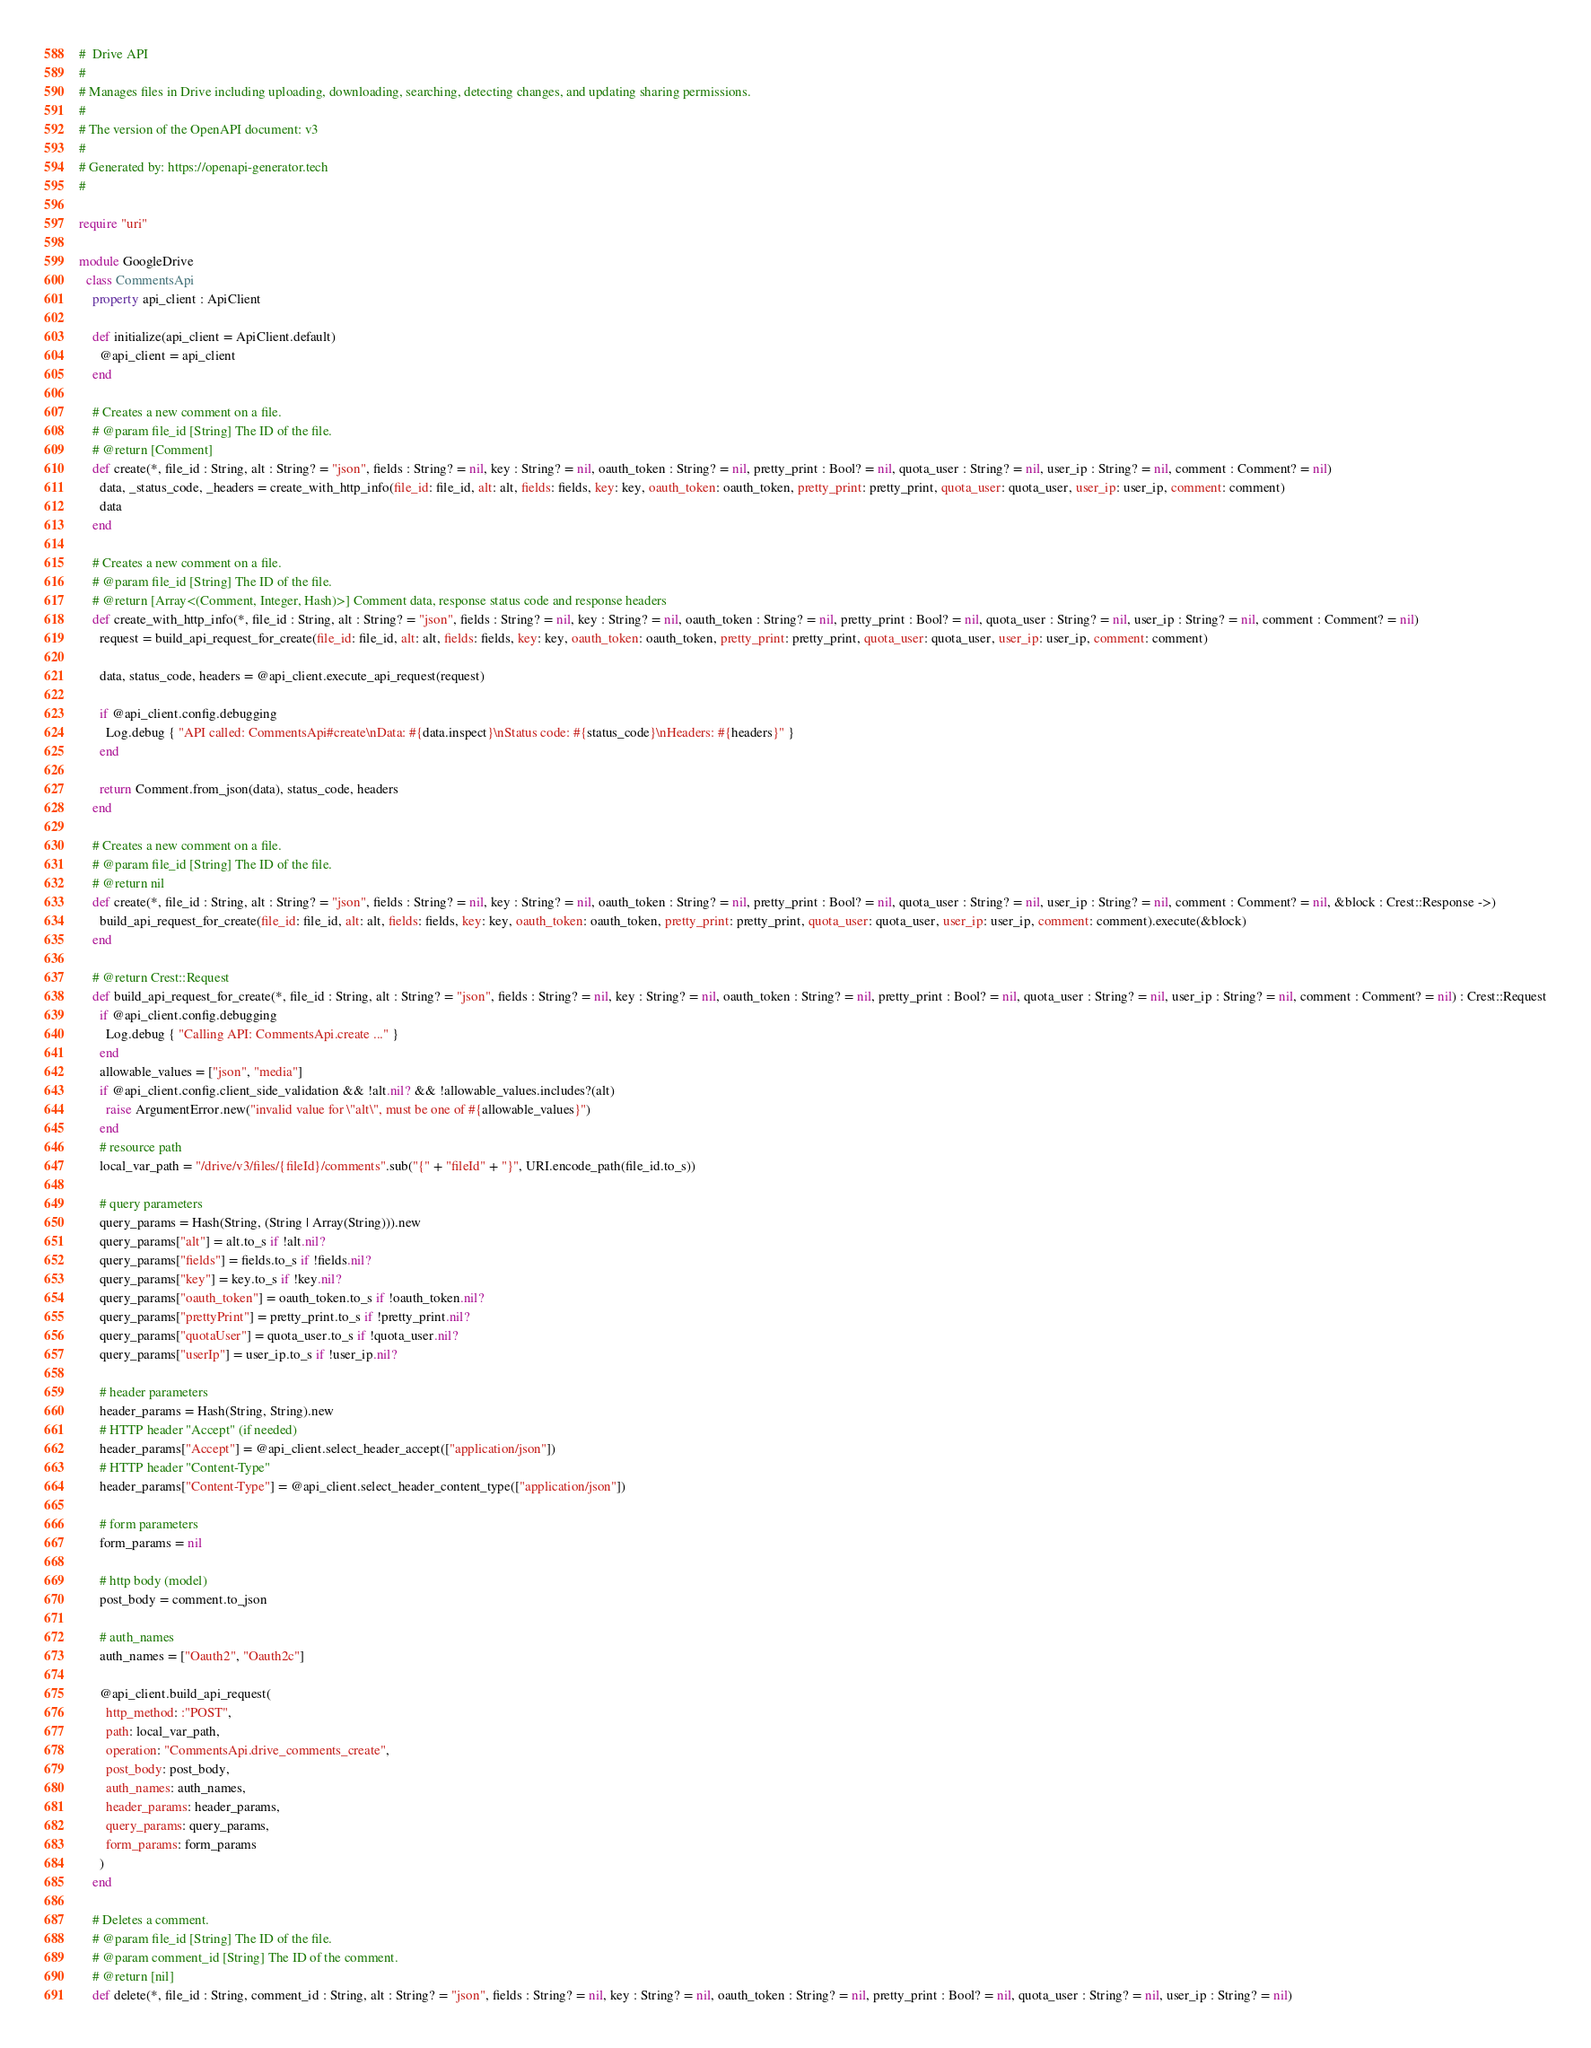<code> <loc_0><loc_0><loc_500><loc_500><_Crystal_>#  Drive API
#
# Manages files in Drive including uploading, downloading, searching, detecting changes, and updating sharing permissions.
#
# The version of the OpenAPI document: v3
#
# Generated by: https://openapi-generator.tech
#

require "uri"

module GoogleDrive
  class CommentsApi
    property api_client : ApiClient

    def initialize(api_client = ApiClient.default)
      @api_client = api_client
    end

    # Creates a new comment on a file.
    # @param file_id [String] The ID of the file.
    # @return [Comment]
    def create(*, file_id : String, alt : String? = "json", fields : String? = nil, key : String? = nil, oauth_token : String? = nil, pretty_print : Bool? = nil, quota_user : String? = nil, user_ip : String? = nil, comment : Comment? = nil)
      data, _status_code, _headers = create_with_http_info(file_id: file_id, alt: alt, fields: fields, key: key, oauth_token: oauth_token, pretty_print: pretty_print, quota_user: quota_user, user_ip: user_ip, comment: comment)
      data
    end

    # Creates a new comment on a file.
    # @param file_id [String] The ID of the file.
    # @return [Array<(Comment, Integer, Hash)>] Comment data, response status code and response headers
    def create_with_http_info(*, file_id : String, alt : String? = "json", fields : String? = nil, key : String? = nil, oauth_token : String? = nil, pretty_print : Bool? = nil, quota_user : String? = nil, user_ip : String? = nil, comment : Comment? = nil)
      request = build_api_request_for_create(file_id: file_id, alt: alt, fields: fields, key: key, oauth_token: oauth_token, pretty_print: pretty_print, quota_user: quota_user, user_ip: user_ip, comment: comment)

      data, status_code, headers = @api_client.execute_api_request(request)

      if @api_client.config.debugging
        Log.debug { "API called: CommentsApi#create\nData: #{data.inspect}\nStatus code: #{status_code}\nHeaders: #{headers}" }
      end

      return Comment.from_json(data), status_code, headers
    end

    # Creates a new comment on a file.
    # @param file_id [String] The ID of the file.
    # @return nil
    def create(*, file_id : String, alt : String? = "json", fields : String? = nil, key : String? = nil, oauth_token : String? = nil, pretty_print : Bool? = nil, quota_user : String? = nil, user_ip : String? = nil, comment : Comment? = nil, &block : Crest::Response ->)
      build_api_request_for_create(file_id: file_id, alt: alt, fields: fields, key: key, oauth_token: oauth_token, pretty_print: pretty_print, quota_user: quota_user, user_ip: user_ip, comment: comment).execute(&block)
    end

    # @return Crest::Request
    def build_api_request_for_create(*, file_id : String, alt : String? = "json", fields : String? = nil, key : String? = nil, oauth_token : String? = nil, pretty_print : Bool? = nil, quota_user : String? = nil, user_ip : String? = nil, comment : Comment? = nil) : Crest::Request
      if @api_client.config.debugging
        Log.debug { "Calling API: CommentsApi.create ..." }
      end
      allowable_values = ["json", "media"]
      if @api_client.config.client_side_validation && !alt.nil? && !allowable_values.includes?(alt)
        raise ArgumentError.new("invalid value for \"alt\", must be one of #{allowable_values}")
      end
      # resource path
      local_var_path = "/drive/v3/files/{fileId}/comments".sub("{" + "fileId" + "}", URI.encode_path(file_id.to_s))

      # query parameters
      query_params = Hash(String, (String | Array(String))).new
      query_params["alt"] = alt.to_s if !alt.nil?
      query_params["fields"] = fields.to_s if !fields.nil?
      query_params["key"] = key.to_s if !key.nil?
      query_params["oauth_token"] = oauth_token.to_s if !oauth_token.nil?
      query_params["prettyPrint"] = pretty_print.to_s if !pretty_print.nil?
      query_params["quotaUser"] = quota_user.to_s if !quota_user.nil?
      query_params["userIp"] = user_ip.to_s if !user_ip.nil?

      # header parameters
      header_params = Hash(String, String).new
      # HTTP header "Accept" (if needed)
      header_params["Accept"] = @api_client.select_header_accept(["application/json"])
      # HTTP header "Content-Type"
      header_params["Content-Type"] = @api_client.select_header_content_type(["application/json"])

      # form parameters
      form_params = nil

      # http body (model)
      post_body = comment.to_json

      # auth_names
      auth_names = ["Oauth2", "Oauth2c"]

      @api_client.build_api_request(
        http_method: :"POST",
        path: local_var_path,
        operation: "CommentsApi.drive_comments_create",
        post_body: post_body,
        auth_names: auth_names,
        header_params: header_params,
        query_params: query_params,
        form_params: form_params
      )
    end

    # Deletes a comment.
    # @param file_id [String] The ID of the file.
    # @param comment_id [String] The ID of the comment.
    # @return [nil]
    def delete(*, file_id : String, comment_id : String, alt : String? = "json", fields : String? = nil, key : String? = nil, oauth_token : String? = nil, pretty_print : Bool? = nil, quota_user : String? = nil, user_ip : String? = nil)</code> 